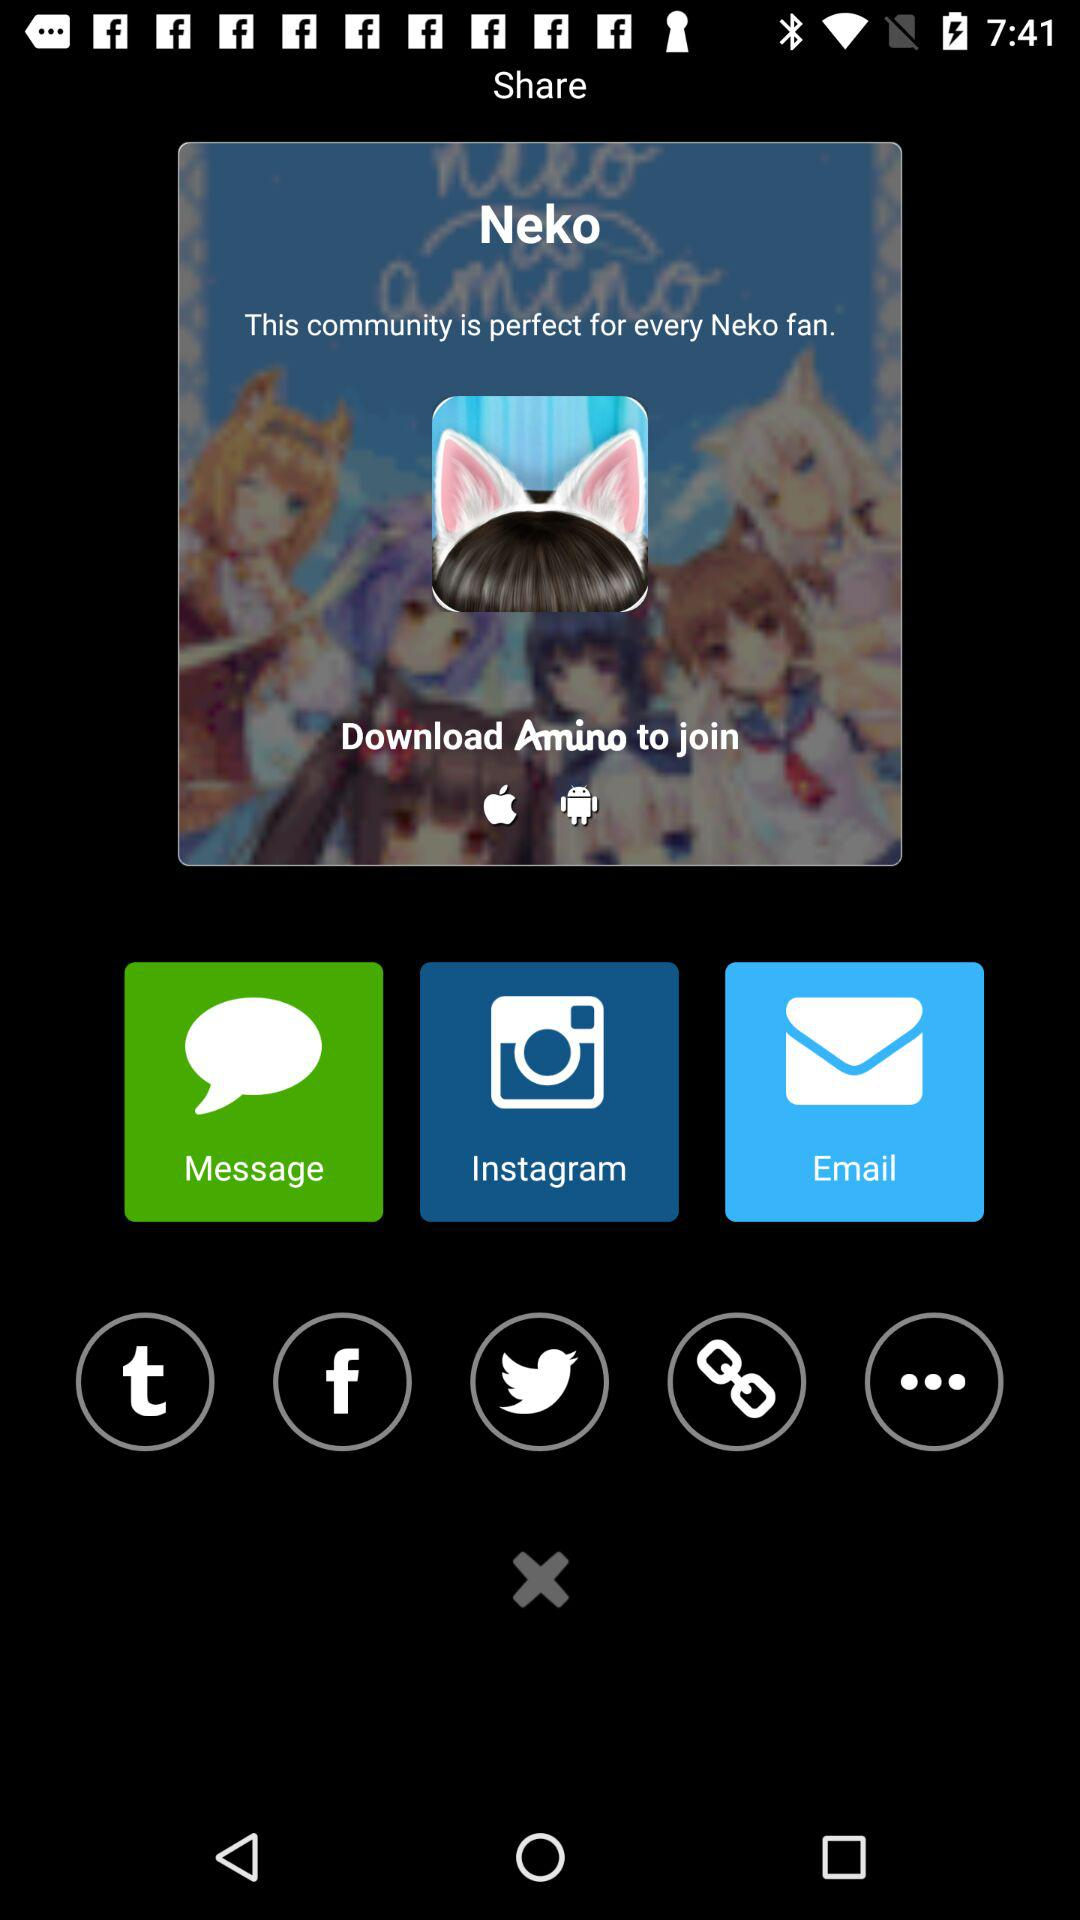What are the different options available to share Neko? The different options to share are "Message", "Instagram" and "Email". 